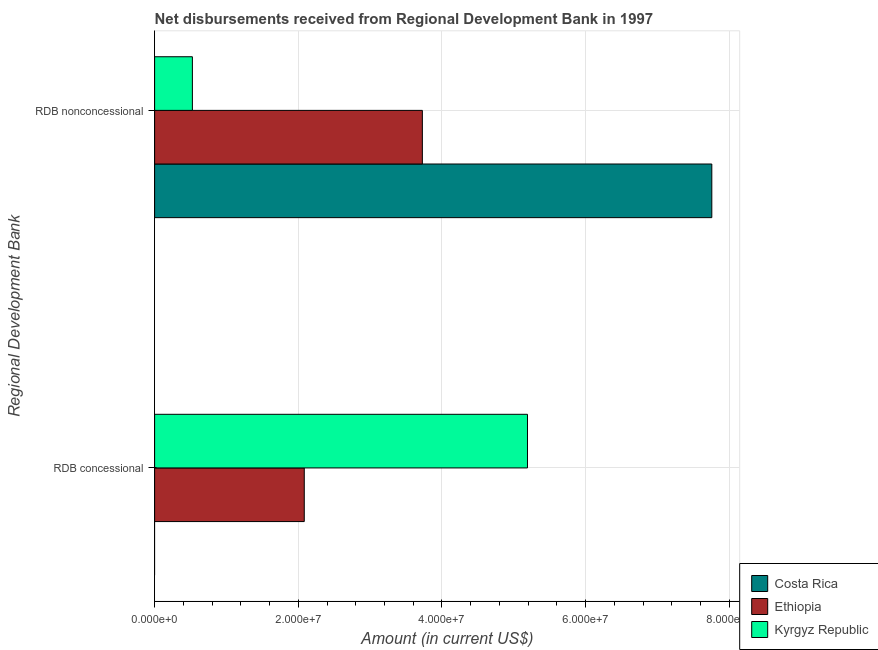How many different coloured bars are there?
Make the answer very short. 3. Are the number of bars per tick equal to the number of legend labels?
Provide a succinct answer. No. Are the number of bars on each tick of the Y-axis equal?
Make the answer very short. No. What is the label of the 2nd group of bars from the top?
Offer a terse response. RDB concessional. What is the net non concessional disbursements from rdb in Kyrgyz Republic?
Give a very brief answer. 5.26e+06. Across all countries, what is the maximum net concessional disbursements from rdb?
Your answer should be very brief. 5.19e+07. Across all countries, what is the minimum net non concessional disbursements from rdb?
Your response must be concise. 5.26e+06. In which country was the net concessional disbursements from rdb maximum?
Make the answer very short. Kyrgyz Republic. What is the total net concessional disbursements from rdb in the graph?
Give a very brief answer. 7.27e+07. What is the difference between the net non concessional disbursements from rdb in Costa Rica and that in Ethiopia?
Provide a short and direct response. 4.03e+07. What is the difference between the net non concessional disbursements from rdb in Costa Rica and the net concessional disbursements from rdb in Ethiopia?
Make the answer very short. 5.67e+07. What is the average net concessional disbursements from rdb per country?
Give a very brief answer. 2.42e+07. What is the difference between the net non concessional disbursements from rdb and net concessional disbursements from rdb in Ethiopia?
Provide a short and direct response. 1.64e+07. In how many countries, is the net concessional disbursements from rdb greater than 40000000 US$?
Give a very brief answer. 1. What is the ratio of the net concessional disbursements from rdb in Ethiopia to that in Kyrgyz Republic?
Offer a terse response. 0.4. Is the net non concessional disbursements from rdb in Kyrgyz Republic less than that in Costa Rica?
Your answer should be very brief. Yes. In how many countries, is the net concessional disbursements from rdb greater than the average net concessional disbursements from rdb taken over all countries?
Offer a very short reply. 1. Are all the bars in the graph horizontal?
Your response must be concise. Yes. What is the difference between two consecutive major ticks on the X-axis?
Provide a short and direct response. 2.00e+07. Where does the legend appear in the graph?
Provide a succinct answer. Bottom right. How many legend labels are there?
Ensure brevity in your answer.  3. What is the title of the graph?
Your response must be concise. Net disbursements received from Regional Development Bank in 1997. What is the label or title of the Y-axis?
Offer a terse response. Regional Development Bank. What is the Amount (in current US$) of Costa Rica in RDB concessional?
Offer a very short reply. 0. What is the Amount (in current US$) in Ethiopia in RDB concessional?
Offer a terse response. 2.08e+07. What is the Amount (in current US$) in Kyrgyz Republic in RDB concessional?
Ensure brevity in your answer.  5.19e+07. What is the Amount (in current US$) of Costa Rica in RDB nonconcessional?
Offer a terse response. 7.76e+07. What is the Amount (in current US$) of Ethiopia in RDB nonconcessional?
Your answer should be compact. 3.73e+07. What is the Amount (in current US$) of Kyrgyz Republic in RDB nonconcessional?
Your response must be concise. 5.26e+06. Across all Regional Development Bank, what is the maximum Amount (in current US$) in Costa Rica?
Offer a very short reply. 7.76e+07. Across all Regional Development Bank, what is the maximum Amount (in current US$) in Ethiopia?
Your answer should be compact. 3.73e+07. Across all Regional Development Bank, what is the maximum Amount (in current US$) in Kyrgyz Republic?
Your response must be concise. 5.19e+07. Across all Regional Development Bank, what is the minimum Amount (in current US$) of Costa Rica?
Provide a succinct answer. 0. Across all Regional Development Bank, what is the minimum Amount (in current US$) of Ethiopia?
Offer a terse response. 2.08e+07. Across all Regional Development Bank, what is the minimum Amount (in current US$) of Kyrgyz Republic?
Make the answer very short. 5.26e+06. What is the total Amount (in current US$) of Costa Rica in the graph?
Ensure brevity in your answer.  7.76e+07. What is the total Amount (in current US$) in Ethiopia in the graph?
Give a very brief answer. 5.81e+07. What is the total Amount (in current US$) of Kyrgyz Republic in the graph?
Provide a short and direct response. 5.72e+07. What is the difference between the Amount (in current US$) in Ethiopia in RDB concessional and that in RDB nonconcessional?
Give a very brief answer. -1.64e+07. What is the difference between the Amount (in current US$) of Kyrgyz Republic in RDB concessional and that in RDB nonconcessional?
Your answer should be compact. 4.66e+07. What is the difference between the Amount (in current US$) of Ethiopia in RDB concessional and the Amount (in current US$) of Kyrgyz Republic in RDB nonconcessional?
Your answer should be compact. 1.56e+07. What is the average Amount (in current US$) of Costa Rica per Regional Development Bank?
Provide a succinct answer. 3.88e+07. What is the average Amount (in current US$) in Ethiopia per Regional Development Bank?
Keep it short and to the point. 2.91e+07. What is the average Amount (in current US$) of Kyrgyz Republic per Regional Development Bank?
Ensure brevity in your answer.  2.86e+07. What is the difference between the Amount (in current US$) in Ethiopia and Amount (in current US$) in Kyrgyz Republic in RDB concessional?
Your response must be concise. -3.11e+07. What is the difference between the Amount (in current US$) of Costa Rica and Amount (in current US$) of Ethiopia in RDB nonconcessional?
Provide a succinct answer. 4.03e+07. What is the difference between the Amount (in current US$) of Costa Rica and Amount (in current US$) of Kyrgyz Republic in RDB nonconcessional?
Keep it short and to the point. 7.23e+07. What is the difference between the Amount (in current US$) of Ethiopia and Amount (in current US$) of Kyrgyz Republic in RDB nonconcessional?
Offer a very short reply. 3.20e+07. What is the ratio of the Amount (in current US$) of Ethiopia in RDB concessional to that in RDB nonconcessional?
Your answer should be very brief. 0.56. What is the ratio of the Amount (in current US$) of Kyrgyz Republic in RDB concessional to that in RDB nonconcessional?
Your answer should be very brief. 9.87. What is the difference between the highest and the second highest Amount (in current US$) of Ethiopia?
Your answer should be compact. 1.64e+07. What is the difference between the highest and the second highest Amount (in current US$) of Kyrgyz Republic?
Make the answer very short. 4.66e+07. What is the difference between the highest and the lowest Amount (in current US$) in Costa Rica?
Give a very brief answer. 7.76e+07. What is the difference between the highest and the lowest Amount (in current US$) of Ethiopia?
Offer a terse response. 1.64e+07. What is the difference between the highest and the lowest Amount (in current US$) of Kyrgyz Republic?
Give a very brief answer. 4.66e+07. 